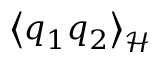Convert formula to latex. <formula><loc_0><loc_0><loc_500><loc_500>\left < q _ { 1 } q _ { 2 } \right > _ { \mathcal { H } }</formula> 